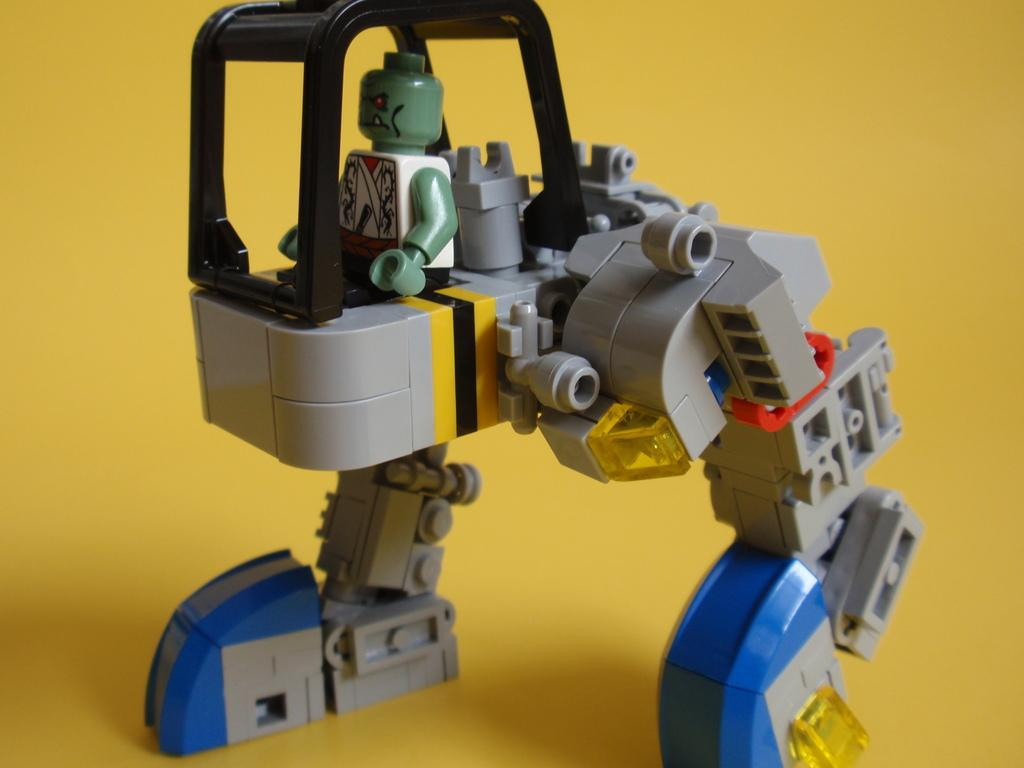What is the main subject in the center of the image? There is a toy in the center of the image. What color is the background of the image? The background of the image is yellow. Can you hear the bells ringing in the image? There are no bells present in the image, so it is not possible to hear them ringing. 